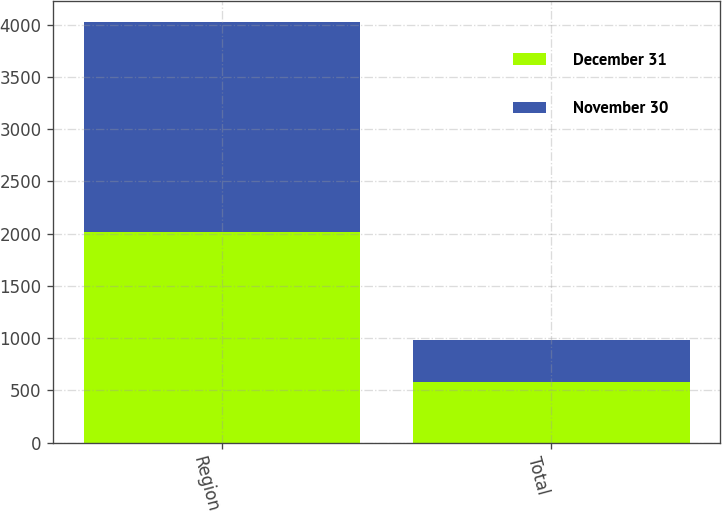<chart> <loc_0><loc_0><loc_500><loc_500><stacked_bar_chart><ecel><fcel>Region<fcel>Total<nl><fcel>December 31<fcel>2012<fcel>581<nl><fcel>November 30<fcel>2010<fcel>403<nl></chart> 